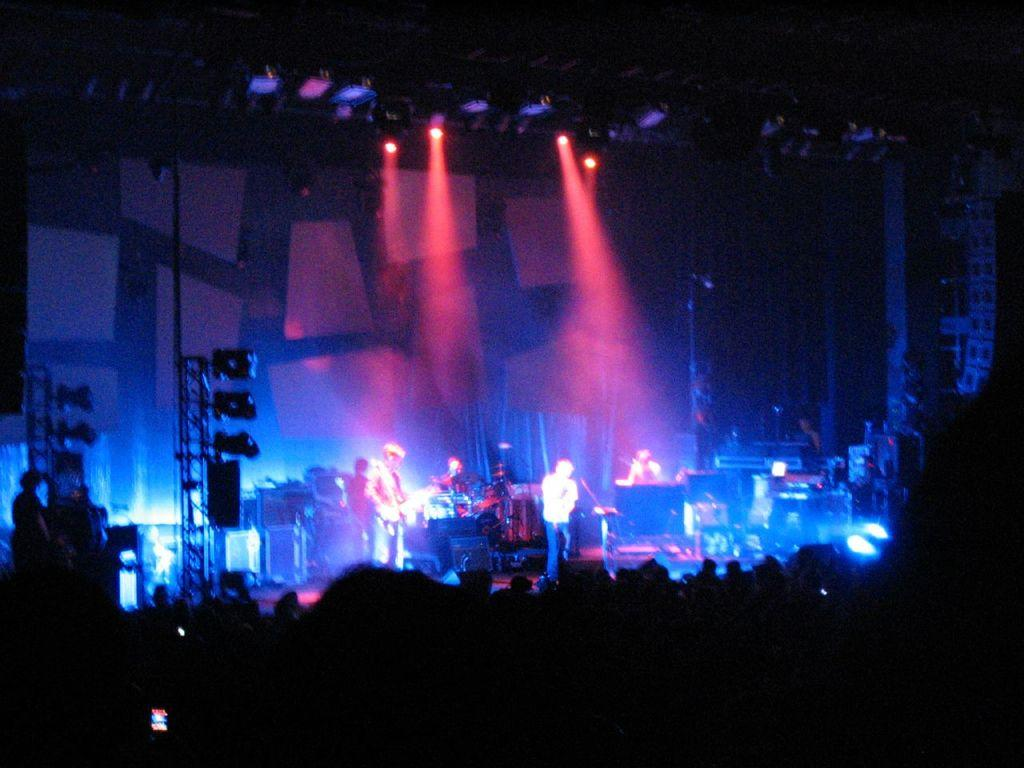What event is happening in the image? A musical concert is taking place in the image. What are the people in the image doing? Multiple people are playing musical instruments. Can you describe the lighting in the image? There are lights visible in the image. How would you describe the visibility of the foreground? The foreground appears to be dark. Can you estimate the number of people present at the concert? It seems like there are many people present at the concert. What type of sand can be seen on the stage during the concert? There is no sand present on the stage during the concert; it is a musical event with people playing instruments. 